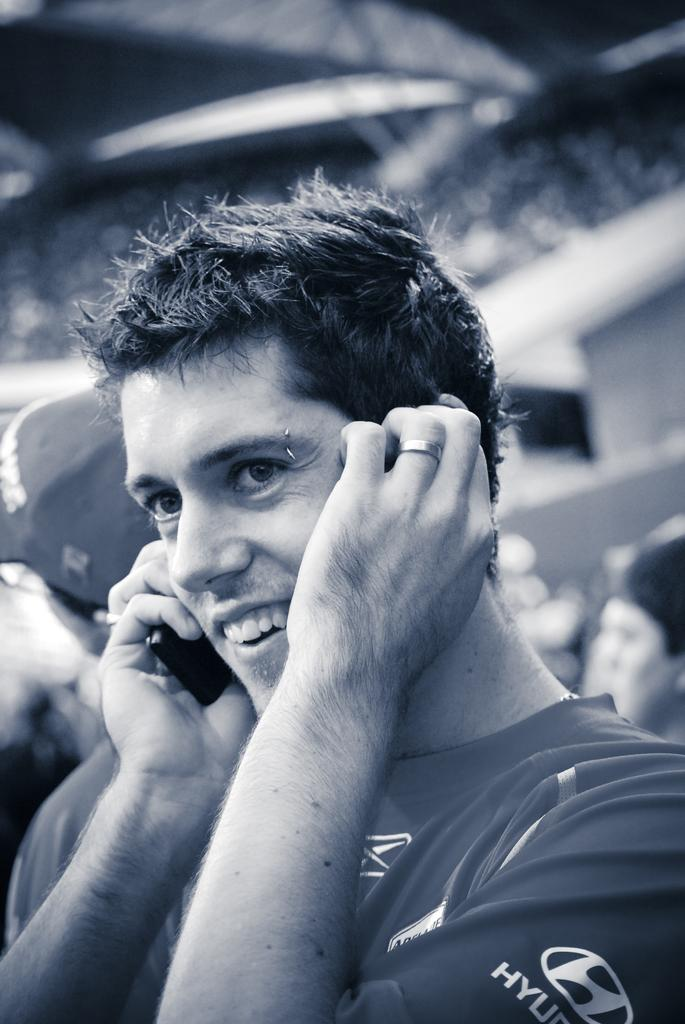What is the main subject of the image? There is a person in the image. What is the person holding in the image? The person is holding a phone. Can you describe the background of the image? The background of the image is blurry. Reasoning: Let's think step by step by step in order to produce the conversation. We start by identifying the main subject of the image, which is the person. Then, we describe what the person is doing or holding, which is a phone. Finally, we mention the background of the image, which is blurry. Each question is designed to elicit a specific detail about the image that is known from the provided facts. Absurd Question/Answer: What type of doctor can be seen in the image? There is no doctor present in the image; it features a person holding a phone. How many ladybugs are visible on the person's shoulder in the image? There are no ladybugs present in the image. What type of book can be seen on the person's lap in the image? There is no book present in the image; it features a person holding a phone. 